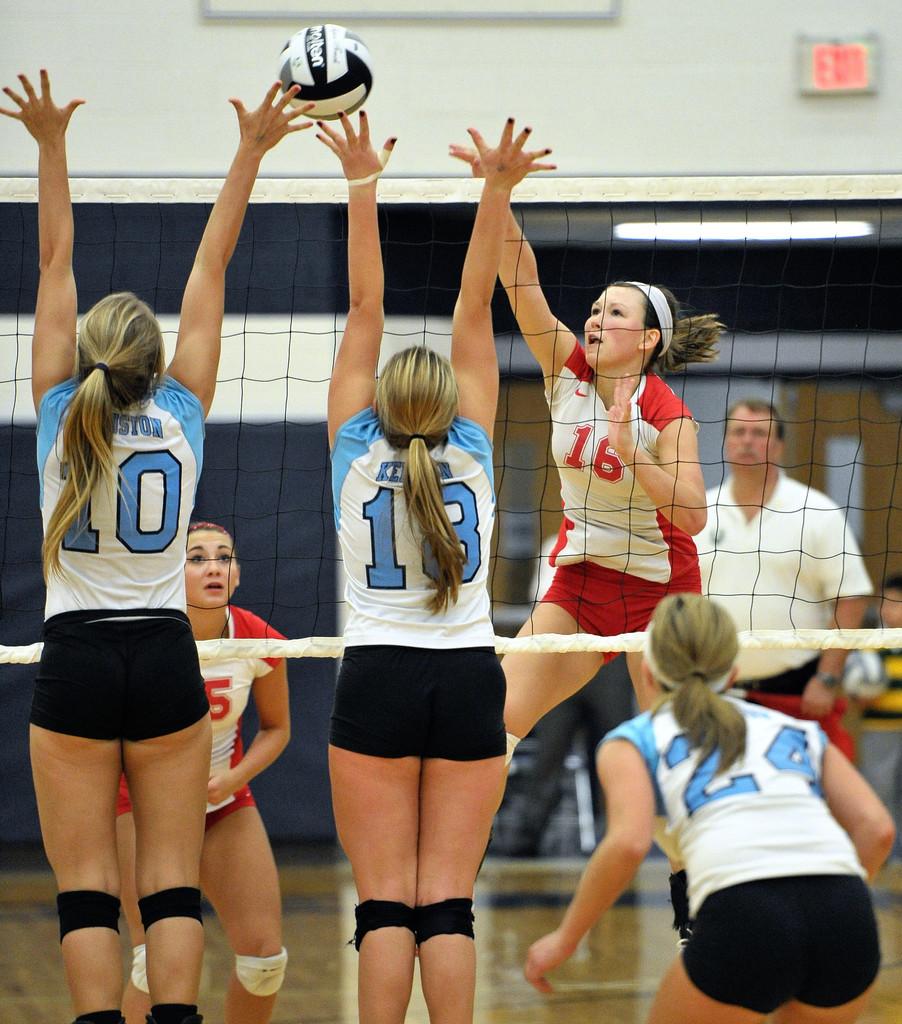What number is the player on the very left?
Make the answer very short. 10. 